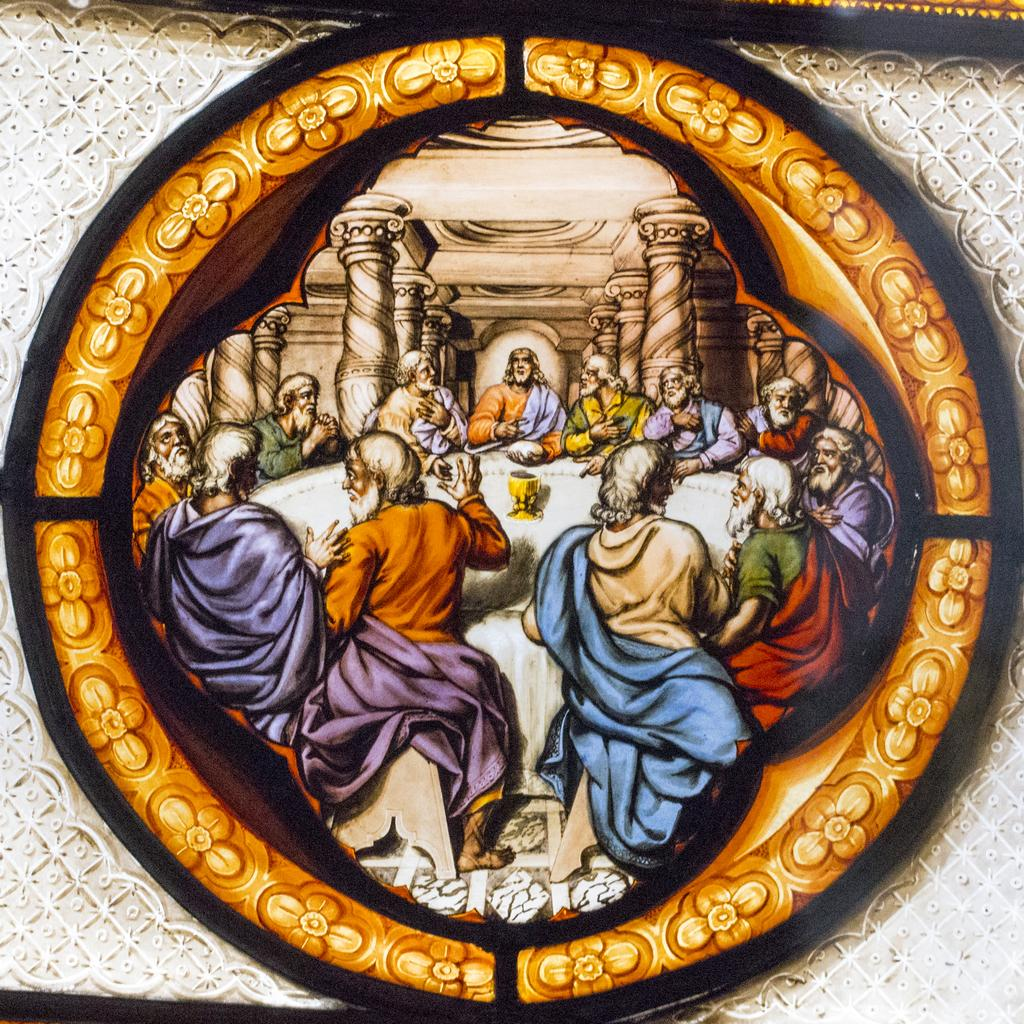What is the main subject in the center of the image? There is a frame in the center of the image. What can be seen inside the frame? There are people sitting around the table in the frame. What is visible in the background of the image? There is a wall and pillars in the background of the image. Can you tell me how many skateboards are leaning against the wall in the image? There are no skateboards present in the image; only a frame, people sitting around a table, a wall, and pillars can be observed. 